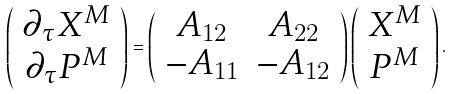Convert formula to latex. <formula><loc_0><loc_0><loc_500><loc_500>\left ( \begin{array} { c } \partial _ { \tau } X ^ { M } \\ \partial _ { \tau } P ^ { M } \end{array} \right ) = \left ( \begin{array} { c c } A _ { 1 2 } & A _ { 2 2 } \\ - A _ { 1 1 } & - A _ { 1 2 } \end{array} \right ) \left ( \begin{array} { c } X ^ { M } \\ P ^ { M } \end{array} \right ) .</formula> 